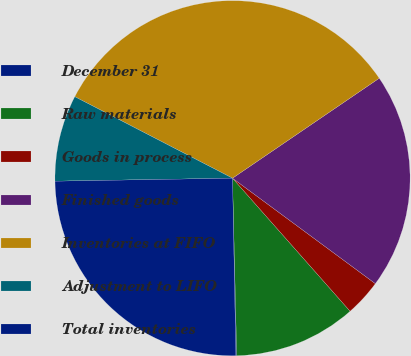Convert chart to OTSL. <chart><loc_0><loc_0><loc_500><loc_500><pie_chart><fcel>December 31<fcel>Raw materials<fcel>Goods in process<fcel>Finished goods<fcel>Inventories at FIFO<fcel>Adjustment to LIFO<fcel>Total inventories<nl><fcel>0.08%<fcel>11.14%<fcel>3.36%<fcel>19.64%<fcel>32.89%<fcel>7.86%<fcel>25.03%<nl></chart> 